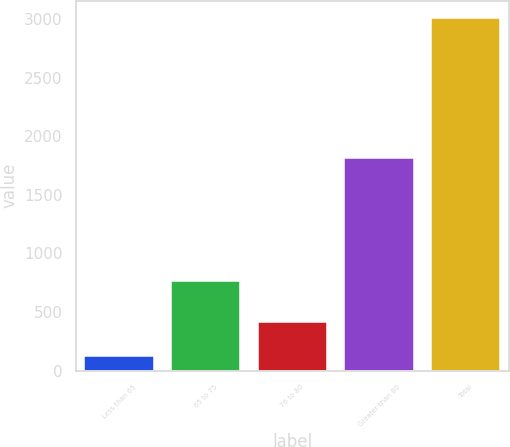Convert chart. <chart><loc_0><loc_0><loc_500><loc_500><bar_chart><fcel>Less than 65<fcel>65 to 75<fcel>76 to 80<fcel>Greater than 80<fcel>Total<nl><fcel>125<fcel>765<fcel>413.2<fcel>1813<fcel>3007<nl></chart> 